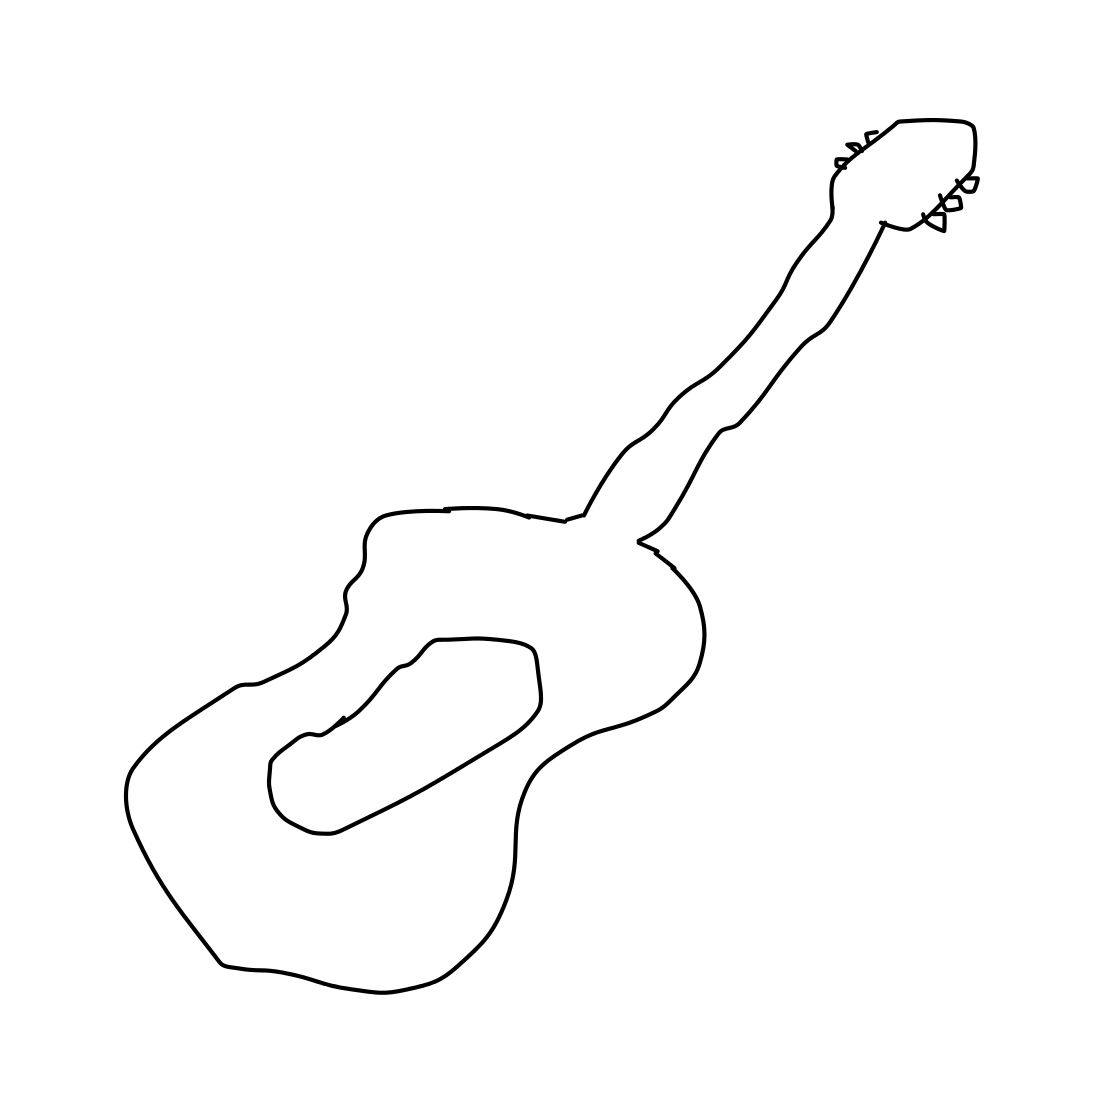In the scene, is a guitar in it? Yes, there is a guitar depicted in the image. It appears to be a classical acoustic guitar with a distinct shape and simple outlines, suggesting a minimalist artistic style. 